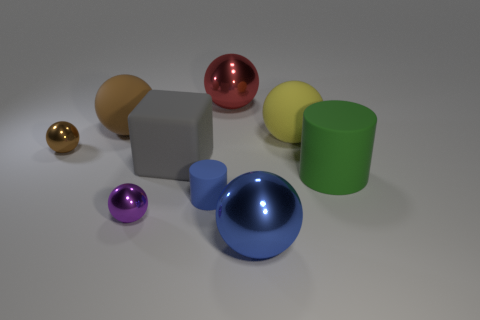There is a large blue thing; what number of spheres are to the left of it?
Ensure brevity in your answer.  4. What is the purple thing made of?
Ensure brevity in your answer.  Metal. Is the color of the matte cube the same as the small matte cylinder?
Your answer should be very brief. No. Is the number of large blocks behind the yellow sphere less than the number of purple metal things?
Offer a terse response. Yes. There is a big shiny sphere in front of the small brown object; what is its color?
Your answer should be very brief. Blue. What shape is the small brown shiny object?
Offer a terse response. Sphere. There is a rubber sphere that is left of the shiny sphere that is behind the yellow sphere; is there a small purple metal object left of it?
Offer a very short reply. No. What color is the big ball that is on the left side of the metal object behind the tiny shiny sphere behind the big gray matte object?
Give a very brief answer. Brown. What is the material of the large green thing that is the same shape as the small blue rubber object?
Your response must be concise. Rubber. There is a matte sphere that is to the left of the cylinder that is on the left side of the green cylinder; what is its size?
Your answer should be compact. Large. 